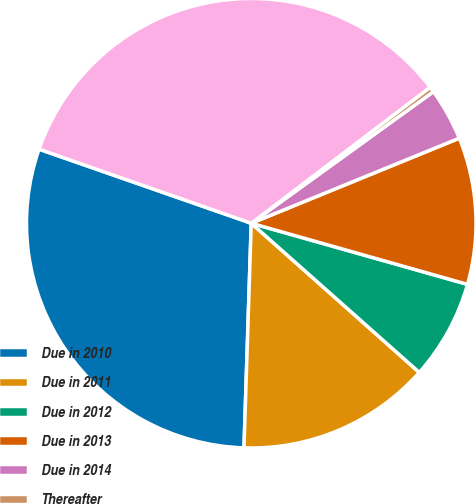Convert chart to OTSL. <chart><loc_0><loc_0><loc_500><loc_500><pie_chart><fcel>Due in 2010<fcel>Due in 2011<fcel>Due in 2012<fcel>Due in 2013<fcel>Due in 2014<fcel>Thereafter<fcel>Total time deposits<nl><fcel>29.83%<fcel>13.96%<fcel>7.17%<fcel>10.56%<fcel>3.78%<fcel>0.39%<fcel>34.31%<nl></chart> 